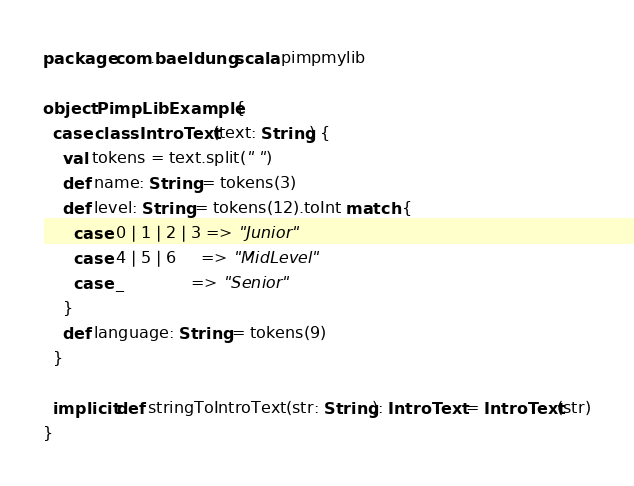Convert code to text. <code><loc_0><loc_0><loc_500><loc_500><_Scala_>package com.baeldung.scala.pimpmylib

object PimpLibExample {
  case class IntroText(text: String) {
    val tokens = text.split(" ")
    def name: String = tokens(3)
    def level: String = tokens(12).toInt match {
      case 0 | 1 | 2 | 3 => "Junior"
      case 4 | 5 | 6     => "MidLevel"
      case _             => "Senior"
    }
    def language: String = tokens(9)
  }

  implicit def stringToIntroText(str: String): IntroText = IntroText(str)
}
</code> 